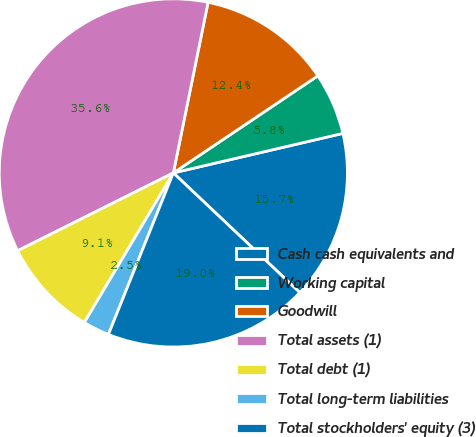Convert chart. <chart><loc_0><loc_0><loc_500><loc_500><pie_chart><fcel>Cash cash equivalents and<fcel>Working capital<fcel>Goodwill<fcel>Total assets (1)<fcel>Total debt (1)<fcel>Total long-term liabilities<fcel>Total stockholders' equity (3)<nl><fcel>15.71%<fcel>5.77%<fcel>12.39%<fcel>35.58%<fcel>9.08%<fcel>2.46%<fcel>19.02%<nl></chart> 